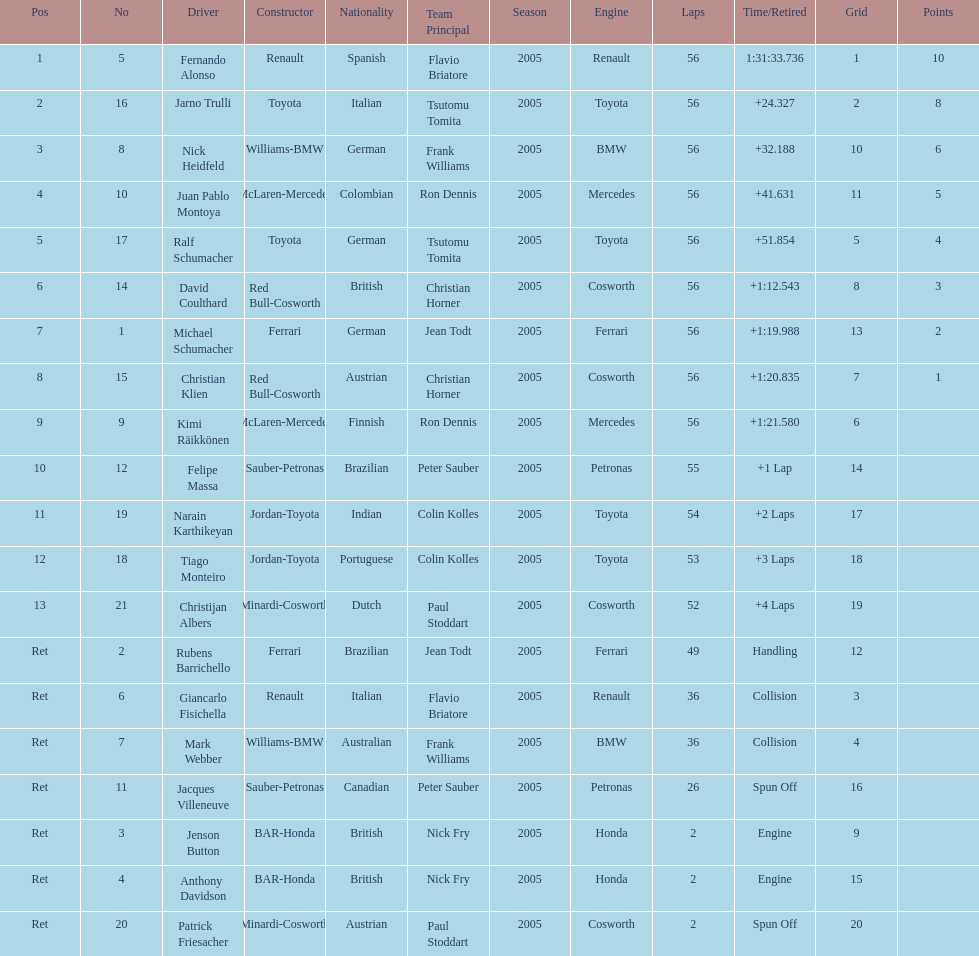What were the total number of laps completed by the 1st position winner? 56. 